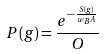Convert formula to latex. <formula><loc_0><loc_0><loc_500><loc_500>P ( g ) = \frac { e ^ { - \frac { S ( g ) } { w _ { B } A } } } { O }</formula> 